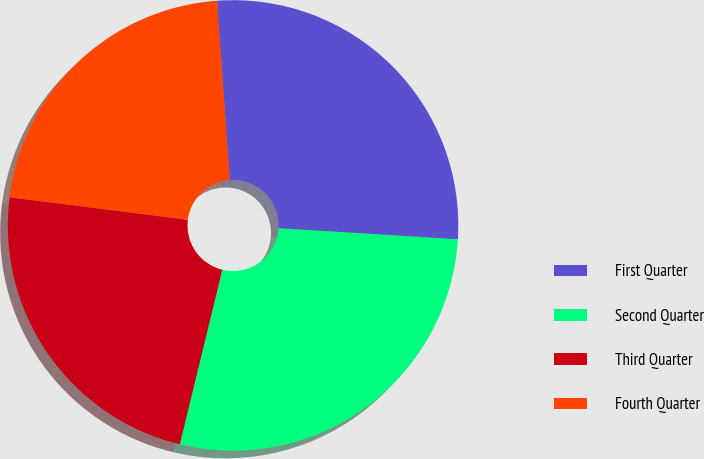Convert chart. <chart><loc_0><loc_0><loc_500><loc_500><pie_chart><fcel>First Quarter<fcel>Second Quarter<fcel>Third Quarter<fcel>Fourth Quarter<nl><fcel>27.12%<fcel>27.82%<fcel>23.19%<fcel>21.87%<nl></chart> 